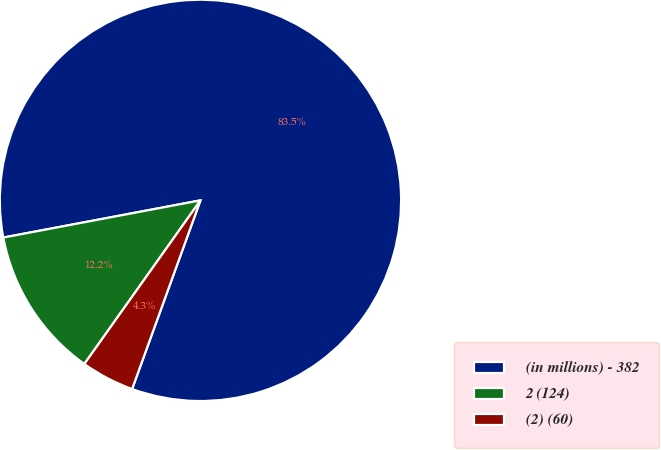<chart> <loc_0><loc_0><loc_500><loc_500><pie_chart><fcel>(in millions) - 382<fcel>2 (124)<fcel>(2) (60)<nl><fcel>83.5%<fcel>12.21%<fcel>4.29%<nl></chart> 